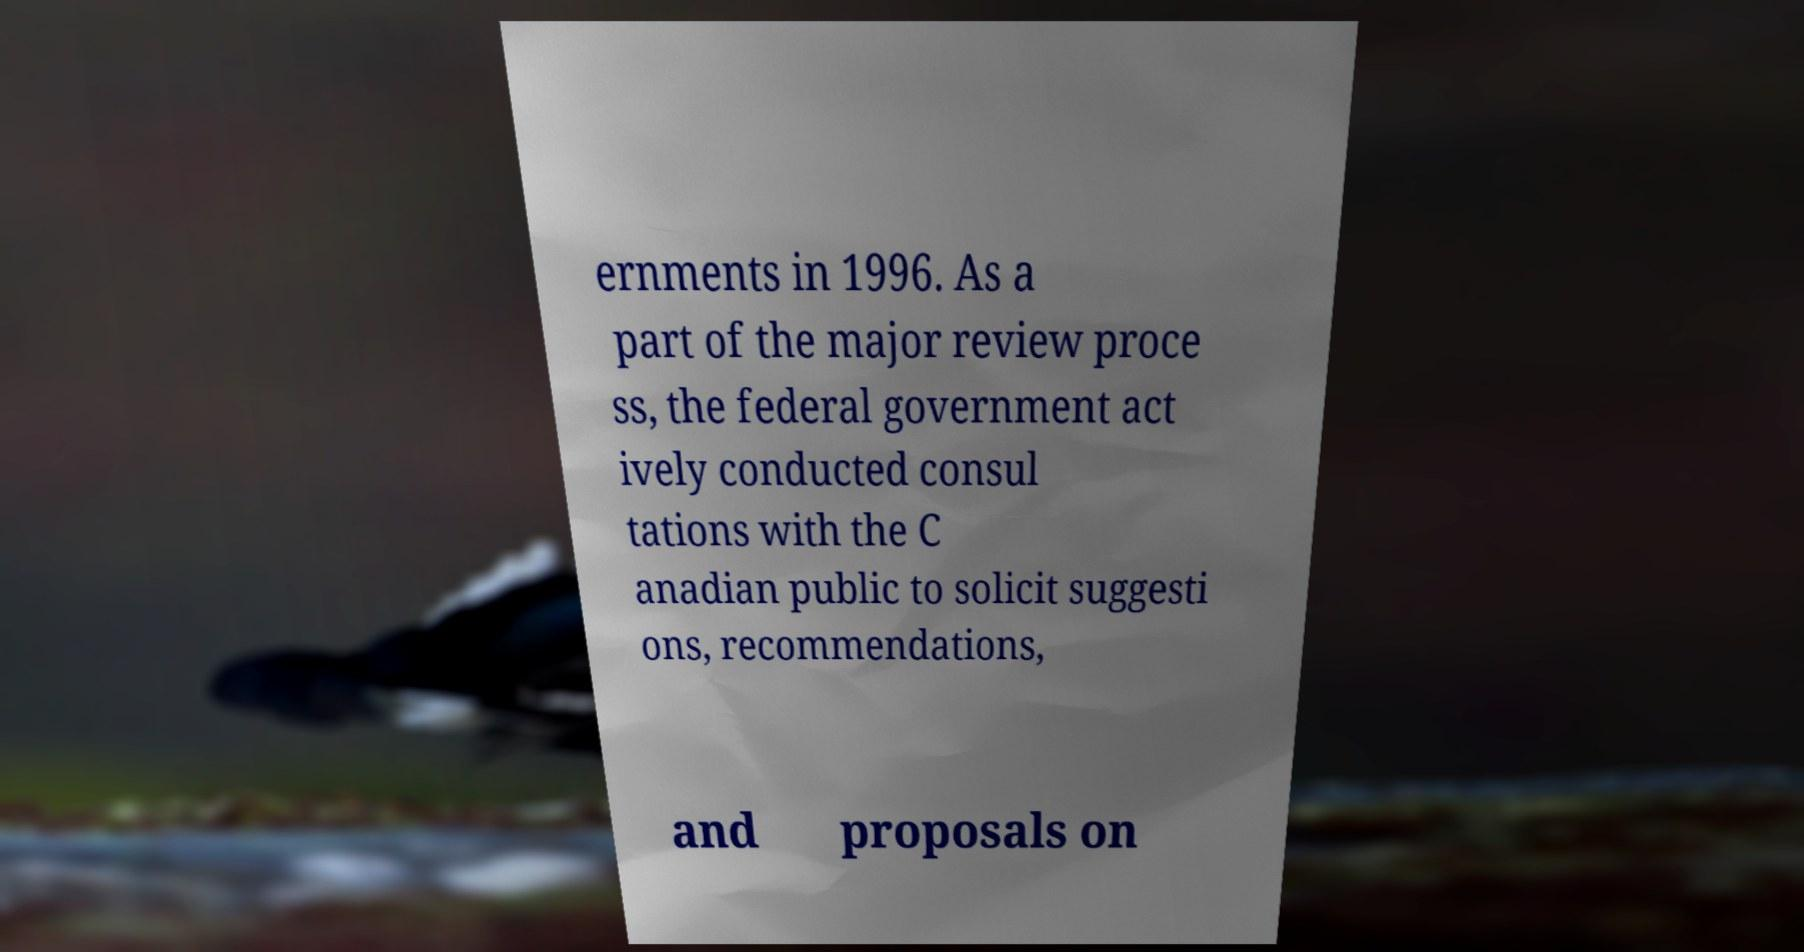For documentation purposes, I need the text within this image transcribed. Could you provide that? ernments in 1996. As a part of the major review proce ss, the federal government act ively conducted consul tations with the C anadian public to solicit suggesti ons, recommendations, and proposals on 